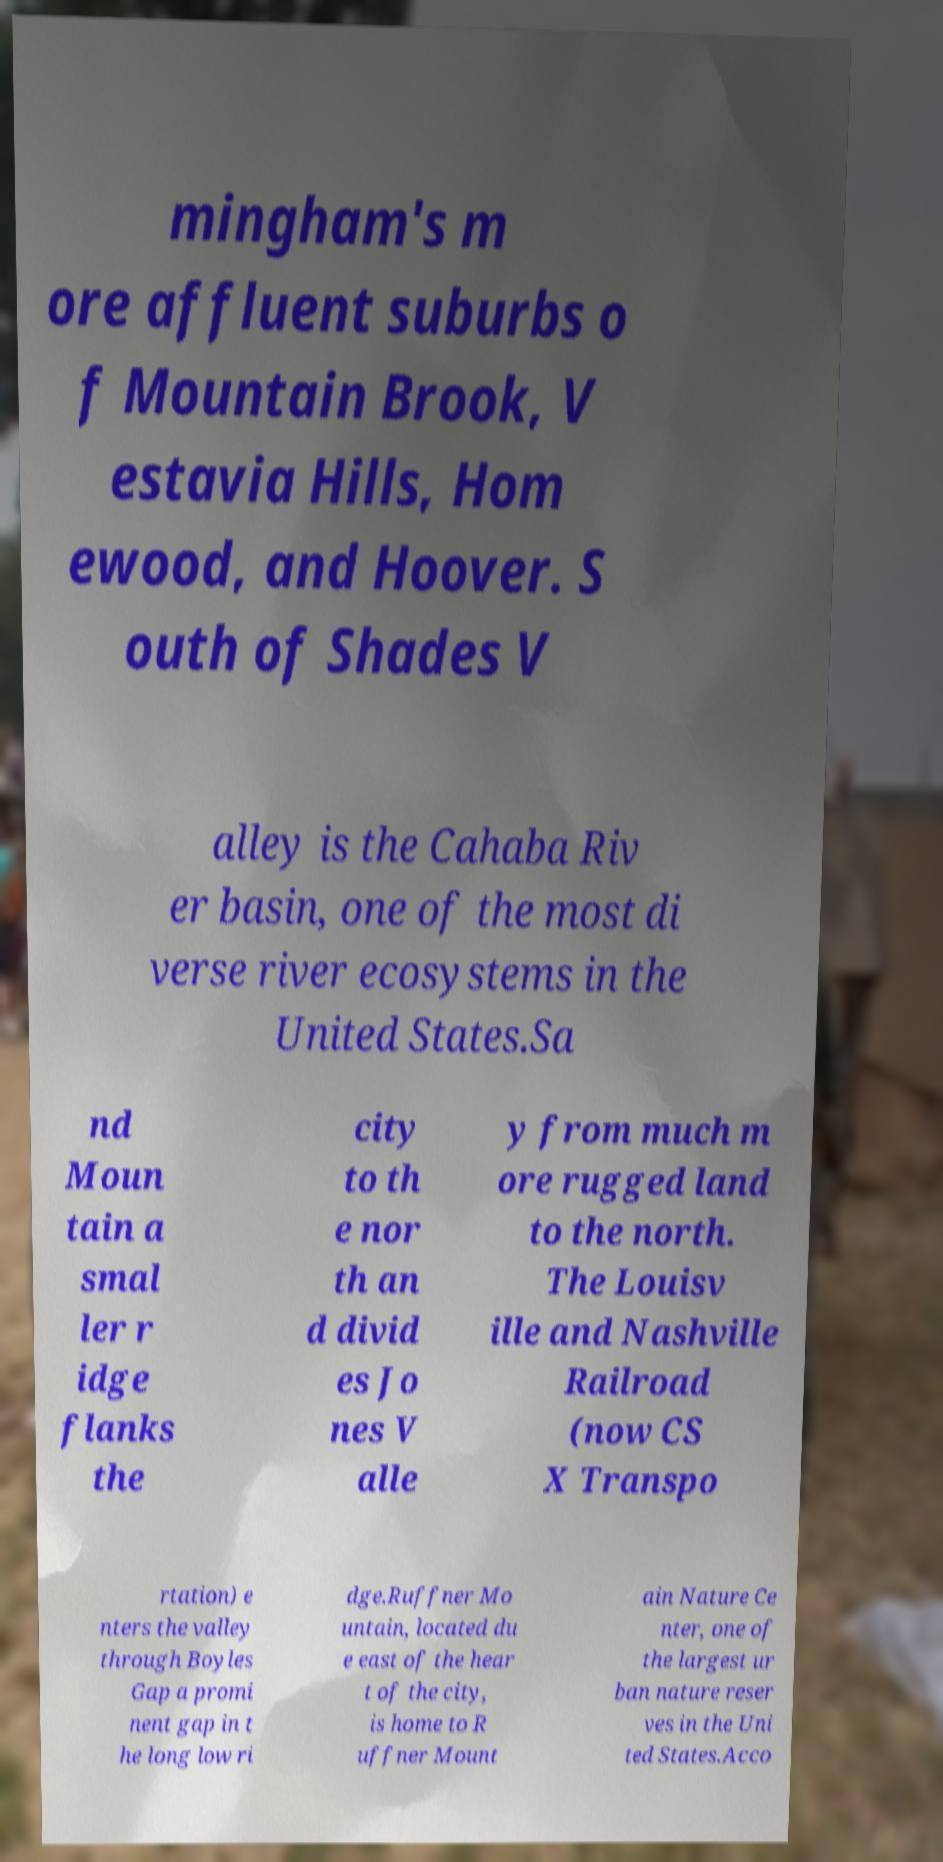Can you accurately transcribe the text from the provided image for me? mingham's m ore affluent suburbs o f Mountain Brook, V estavia Hills, Hom ewood, and Hoover. S outh of Shades V alley is the Cahaba Riv er basin, one of the most di verse river ecosystems in the United States.Sa nd Moun tain a smal ler r idge flanks the city to th e nor th an d divid es Jo nes V alle y from much m ore rugged land to the north. The Louisv ille and Nashville Railroad (now CS X Transpo rtation) e nters the valley through Boyles Gap a promi nent gap in t he long low ri dge.Ruffner Mo untain, located du e east of the hear t of the city, is home to R uffner Mount ain Nature Ce nter, one of the largest ur ban nature reser ves in the Uni ted States.Acco 